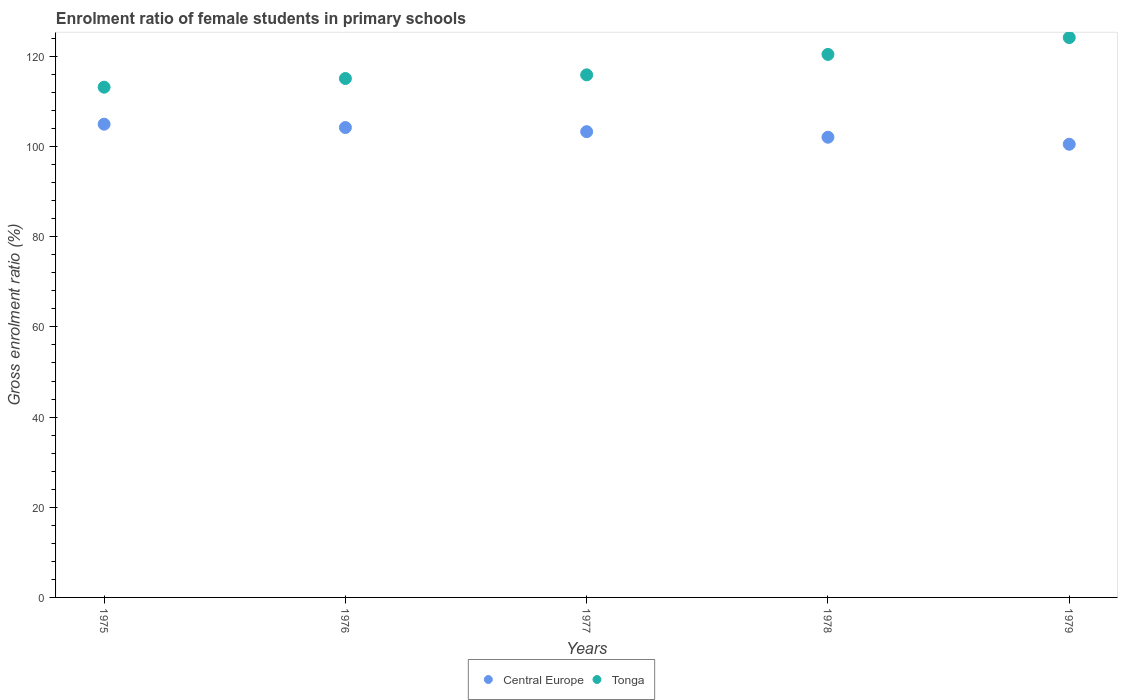What is the enrolment ratio of female students in primary schools in Tonga in 1978?
Make the answer very short. 120.44. Across all years, what is the maximum enrolment ratio of female students in primary schools in Tonga?
Provide a succinct answer. 124.17. Across all years, what is the minimum enrolment ratio of female students in primary schools in Tonga?
Your answer should be compact. 113.17. In which year was the enrolment ratio of female students in primary schools in Tonga maximum?
Ensure brevity in your answer.  1979. In which year was the enrolment ratio of female students in primary schools in Central Europe minimum?
Ensure brevity in your answer.  1979. What is the total enrolment ratio of female students in primary schools in Central Europe in the graph?
Your answer should be compact. 515.08. What is the difference between the enrolment ratio of female students in primary schools in Tonga in 1977 and that in 1978?
Your response must be concise. -4.53. What is the difference between the enrolment ratio of female students in primary schools in Tonga in 1976 and the enrolment ratio of female students in primary schools in Central Europe in 1977?
Ensure brevity in your answer.  11.79. What is the average enrolment ratio of female students in primary schools in Central Europe per year?
Ensure brevity in your answer.  103.02. In the year 1975, what is the difference between the enrolment ratio of female students in primary schools in Central Europe and enrolment ratio of female students in primary schools in Tonga?
Your answer should be compact. -8.21. In how many years, is the enrolment ratio of female students in primary schools in Tonga greater than 20 %?
Your answer should be compact. 5. What is the ratio of the enrolment ratio of female students in primary schools in Tonga in 1975 to that in 1977?
Ensure brevity in your answer.  0.98. What is the difference between the highest and the second highest enrolment ratio of female students in primary schools in Tonga?
Your answer should be compact. 3.73. What is the difference between the highest and the lowest enrolment ratio of female students in primary schools in Central Europe?
Provide a succinct answer. 4.45. In how many years, is the enrolment ratio of female students in primary schools in Tonga greater than the average enrolment ratio of female students in primary schools in Tonga taken over all years?
Make the answer very short. 2. Does the enrolment ratio of female students in primary schools in Tonga monotonically increase over the years?
Offer a very short reply. Yes. Are the values on the major ticks of Y-axis written in scientific E-notation?
Keep it short and to the point. No. Does the graph contain any zero values?
Offer a terse response. No. What is the title of the graph?
Provide a succinct answer. Enrolment ratio of female students in primary schools. What is the Gross enrolment ratio (%) of Central Europe in 1975?
Your answer should be compact. 104.97. What is the Gross enrolment ratio (%) of Tonga in 1975?
Your answer should be compact. 113.17. What is the Gross enrolment ratio (%) in Central Europe in 1976?
Give a very brief answer. 104.22. What is the Gross enrolment ratio (%) of Tonga in 1976?
Provide a short and direct response. 115.1. What is the Gross enrolment ratio (%) of Central Europe in 1977?
Your answer should be very brief. 103.3. What is the Gross enrolment ratio (%) of Tonga in 1977?
Make the answer very short. 115.91. What is the Gross enrolment ratio (%) in Central Europe in 1978?
Give a very brief answer. 102.07. What is the Gross enrolment ratio (%) in Tonga in 1978?
Your answer should be very brief. 120.44. What is the Gross enrolment ratio (%) in Central Europe in 1979?
Provide a succinct answer. 100.52. What is the Gross enrolment ratio (%) in Tonga in 1979?
Ensure brevity in your answer.  124.17. Across all years, what is the maximum Gross enrolment ratio (%) in Central Europe?
Provide a short and direct response. 104.97. Across all years, what is the maximum Gross enrolment ratio (%) in Tonga?
Ensure brevity in your answer.  124.17. Across all years, what is the minimum Gross enrolment ratio (%) of Central Europe?
Your response must be concise. 100.52. Across all years, what is the minimum Gross enrolment ratio (%) of Tonga?
Keep it short and to the point. 113.17. What is the total Gross enrolment ratio (%) in Central Europe in the graph?
Provide a short and direct response. 515.08. What is the total Gross enrolment ratio (%) of Tonga in the graph?
Offer a terse response. 588.8. What is the difference between the Gross enrolment ratio (%) in Central Europe in 1975 and that in 1976?
Your answer should be compact. 0.74. What is the difference between the Gross enrolment ratio (%) of Tonga in 1975 and that in 1976?
Offer a terse response. -1.93. What is the difference between the Gross enrolment ratio (%) in Central Europe in 1975 and that in 1977?
Offer a terse response. 1.66. What is the difference between the Gross enrolment ratio (%) of Tonga in 1975 and that in 1977?
Your response must be concise. -2.74. What is the difference between the Gross enrolment ratio (%) in Central Europe in 1975 and that in 1978?
Provide a short and direct response. 2.89. What is the difference between the Gross enrolment ratio (%) of Tonga in 1975 and that in 1978?
Provide a short and direct response. -7.27. What is the difference between the Gross enrolment ratio (%) of Central Europe in 1975 and that in 1979?
Provide a succinct answer. 4.45. What is the difference between the Gross enrolment ratio (%) of Tonga in 1975 and that in 1979?
Make the answer very short. -11. What is the difference between the Gross enrolment ratio (%) of Central Europe in 1976 and that in 1977?
Ensure brevity in your answer.  0.92. What is the difference between the Gross enrolment ratio (%) in Tonga in 1976 and that in 1977?
Your answer should be very brief. -0.81. What is the difference between the Gross enrolment ratio (%) of Central Europe in 1976 and that in 1978?
Your answer should be very brief. 2.15. What is the difference between the Gross enrolment ratio (%) in Tonga in 1976 and that in 1978?
Make the answer very short. -5.34. What is the difference between the Gross enrolment ratio (%) in Central Europe in 1976 and that in 1979?
Give a very brief answer. 3.71. What is the difference between the Gross enrolment ratio (%) of Tonga in 1976 and that in 1979?
Provide a short and direct response. -9.08. What is the difference between the Gross enrolment ratio (%) in Central Europe in 1977 and that in 1978?
Provide a succinct answer. 1.23. What is the difference between the Gross enrolment ratio (%) of Tonga in 1977 and that in 1978?
Your response must be concise. -4.53. What is the difference between the Gross enrolment ratio (%) of Central Europe in 1977 and that in 1979?
Offer a terse response. 2.79. What is the difference between the Gross enrolment ratio (%) in Tonga in 1977 and that in 1979?
Provide a short and direct response. -8.27. What is the difference between the Gross enrolment ratio (%) of Central Europe in 1978 and that in 1979?
Give a very brief answer. 1.56. What is the difference between the Gross enrolment ratio (%) in Tonga in 1978 and that in 1979?
Ensure brevity in your answer.  -3.73. What is the difference between the Gross enrolment ratio (%) in Central Europe in 1975 and the Gross enrolment ratio (%) in Tonga in 1976?
Offer a terse response. -10.13. What is the difference between the Gross enrolment ratio (%) in Central Europe in 1975 and the Gross enrolment ratio (%) in Tonga in 1977?
Your answer should be compact. -10.94. What is the difference between the Gross enrolment ratio (%) of Central Europe in 1975 and the Gross enrolment ratio (%) of Tonga in 1978?
Keep it short and to the point. -15.48. What is the difference between the Gross enrolment ratio (%) in Central Europe in 1975 and the Gross enrolment ratio (%) in Tonga in 1979?
Offer a terse response. -19.21. What is the difference between the Gross enrolment ratio (%) of Central Europe in 1976 and the Gross enrolment ratio (%) of Tonga in 1977?
Provide a short and direct response. -11.68. What is the difference between the Gross enrolment ratio (%) of Central Europe in 1976 and the Gross enrolment ratio (%) of Tonga in 1978?
Keep it short and to the point. -16.22. What is the difference between the Gross enrolment ratio (%) of Central Europe in 1976 and the Gross enrolment ratio (%) of Tonga in 1979?
Give a very brief answer. -19.95. What is the difference between the Gross enrolment ratio (%) in Central Europe in 1977 and the Gross enrolment ratio (%) in Tonga in 1978?
Ensure brevity in your answer.  -17.14. What is the difference between the Gross enrolment ratio (%) in Central Europe in 1977 and the Gross enrolment ratio (%) in Tonga in 1979?
Offer a very short reply. -20.87. What is the difference between the Gross enrolment ratio (%) in Central Europe in 1978 and the Gross enrolment ratio (%) in Tonga in 1979?
Your answer should be compact. -22.1. What is the average Gross enrolment ratio (%) of Central Europe per year?
Offer a very short reply. 103.02. What is the average Gross enrolment ratio (%) of Tonga per year?
Ensure brevity in your answer.  117.76. In the year 1975, what is the difference between the Gross enrolment ratio (%) in Central Europe and Gross enrolment ratio (%) in Tonga?
Give a very brief answer. -8.21. In the year 1976, what is the difference between the Gross enrolment ratio (%) in Central Europe and Gross enrolment ratio (%) in Tonga?
Ensure brevity in your answer.  -10.87. In the year 1977, what is the difference between the Gross enrolment ratio (%) in Central Europe and Gross enrolment ratio (%) in Tonga?
Ensure brevity in your answer.  -12.61. In the year 1978, what is the difference between the Gross enrolment ratio (%) of Central Europe and Gross enrolment ratio (%) of Tonga?
Your response must be concise. -18.37. In the year 1979, what is the difference between the Gross enrolment ratio (%) of Central Europe and Gross enrolment ratio (%) of Tonga?
Your answer should be very brief. -23.66. What is the ratio of the Gross enrolment ratio (%) of Central Europe in 1975 to that in 1976?
Provide a short and direct response. 1.01. What is the ratio of the Gross enrolment ratio (%) of Tonga in 1975 to that in 1976?
Provide a succinct answer. 0.98. What is the ratio of the Gross enrolment ratio (%) of Central Europe in 1975 to that in 1977?
Provide a succinct answer. 1.02. What is the ratio of the Gross enrolment ratio (%) in Tonga in 1975 to that in 1977?
Your response must be concise. 0.98. What is the ratio of the Gross enrolment ratio (%) of Central Europe in 1975 to that in 1978?
Offer a terse response. 1.03. What is the ratio of the Gross enrolment ratio (%) in Tonga in 1975 to that in 1978?
Provide a short and direct response. 0.94. What is the ratio of the Gross enrolment ratio (%) in Central Europe in 1975 to that in 1979?
Give a very brief answer. 1.04. What is the ratio of the Gross enrolment ratio (%) of Tonga in 1975 to that in 1979?
Your answer should be very brief. 0.91. What is the ratio of the Gross enrolment ratio (%) in Central Europe in 1976 to that in 1977?
Offer a terse response. 1.01. What is the ratio of the Gross enrolment ratio (%) of Central Europe in 1976 to that in 1978?
Your answer should be very brief. 1.02. What is the ratio of the Gross enrolment ratio (%) in Tonga in 1976 to that in 1978?
Offer a very short reply. 0.96. What is the ratio of the Gross enrolment ratio (%) in Central Europe in 1976 to that in 1979?
Your answer should be compact. 1.04. What is the ratio of the Gross enrolment ratio (%) in Tonga in 1976 to that in 1979?
Your response must be concise. 0.93. What is the ratio of the Gross enrolment ratio (%) in Central Europe in 1977 to that in 1978?
Your answer should be very brief. 1.01. What is the ratio of the Gross enrolment ratio (%) of Tonga in 1977 to that in 1978?
Offer a very short reply. 0.96. What is the ratio of the Gross enrolment ratio (%) in Central Europe in 1977 to that in 1979?
Your answer should be very brief. 1.03. What is the ratio of the Gross enrolment ratio (%) of Tonga in 1977 to that in 1979?
Give a very brief answer. 0.93. What is the ratio of the Gross enrolment ratio (%) of Central Europe in 1978 to that in 1979?
Give a very brief answer. 1.02. What is the ratio of the Gross enrolment ratio (%) in Tonga in 1978 to that in 1979?
Ensure brevity in your answer.  0.97. What is the difference between the highest and the second highest Gross enrolment ratio (%) of Central Europe?
Offer a very short reply. 0.74. What is the difference between the highest and the second highest Gross enrolment ratio (%) in Tonga?
Offer a very short reply. 3.73. What is the difference between the highest and the lowest Gross enrolment ratio (%) of Central Europe?
Your answer should be very brief. 4.45. What is the difference between the highest and the lowest Gross enrolment ratio (%) in Tonga?
Provide a succinct answer. 11. 